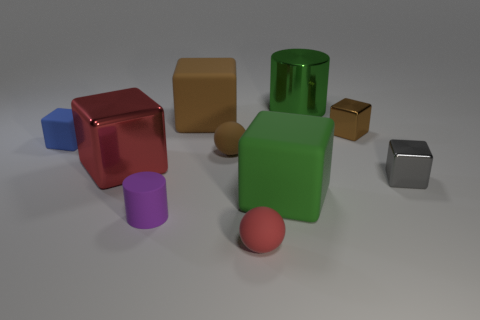Subtract 1 blocks. How many blocks are left? 5 Subtract all red blocks. How many blocks are left? 5 Subtract all green matte cubes. How many cubes are left? 5 Subtract all big brown metallic balls. Subtract all small brown balls. How many objects are left? 9 Add 4 tiny gray things. How many tiny gray things are left? 5 Add 1 big green things. How many big green things exist? 3 Subtract 0 blue spheres. How many objects are left? 10 Subtract all spheres. How many objects are left? 8 Subtract all cyan blocks. Subtract all purple spheres. How many blocks are left? 6 